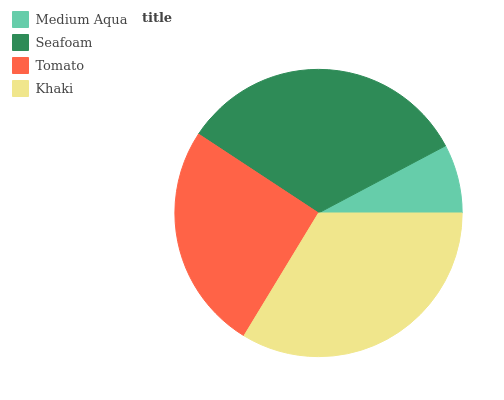Is Medium Aqua the minimum?
Answer yes or no. Yes. Is Khaki the maximum?
Answer yes or no. Yes. Is Seafoam the minimum?
Answer yes or no. No. Is Seafoam the maximum?
Answer yes or no. No. Is Seafoam greater than Medium Aqua?
Answer yes or no. Yes. Is Medium Aqua less than Seafoam?
Answer yes or no. Yes. Is Medium Aqua greater than Seafoam?
Answer yes or no. No. Is Seafoam less than Medium Aqua?
Answer yes or no. No. Is Seafoam the high median?
Answer yes or no. Yes. Is Tomato the low median?
Answer yes or no. Yes. Is Medium Aqua the high median?
Answer yes or no. No. Is Khaki the low median?
Answer yes or no. No. 